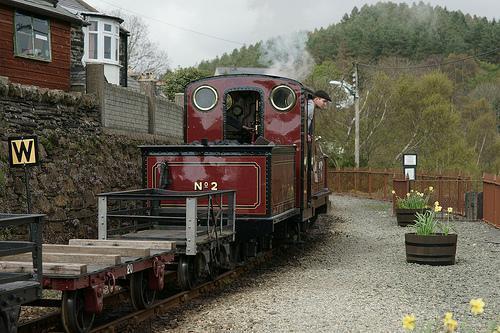How many trains are pictured?
Give a very brief answer. 1. 